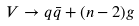Convert formula to latex. <formula><loc_0><loc_0><loc_500><loc_500>V \rightarrow q \bar { q } + ( n - 2 ) g</formula> 